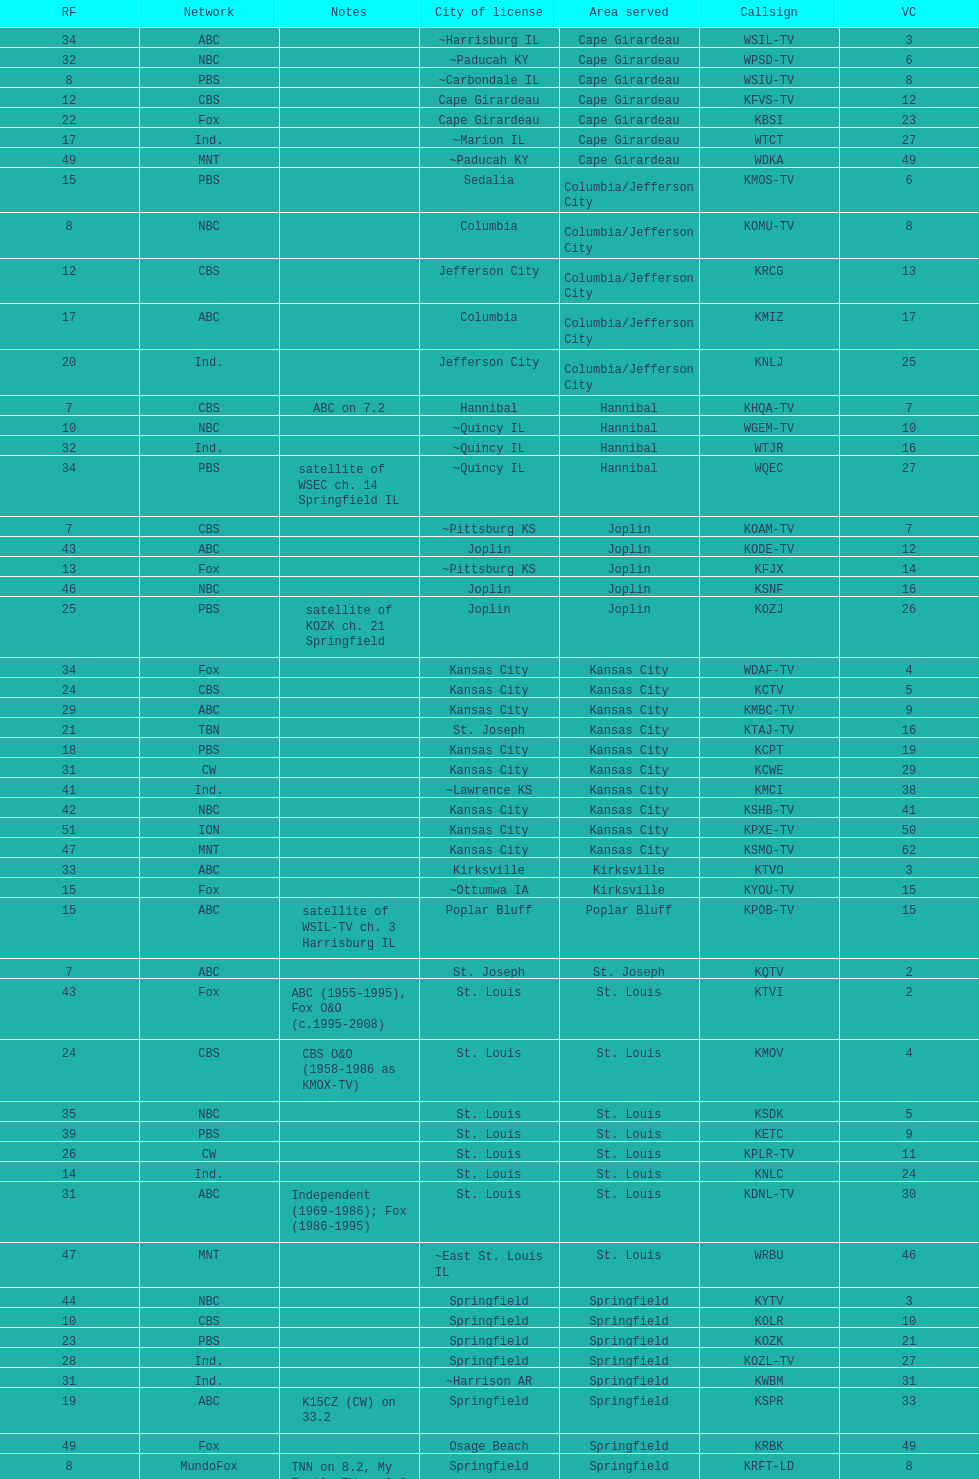How many are on the cbs network? 7. 